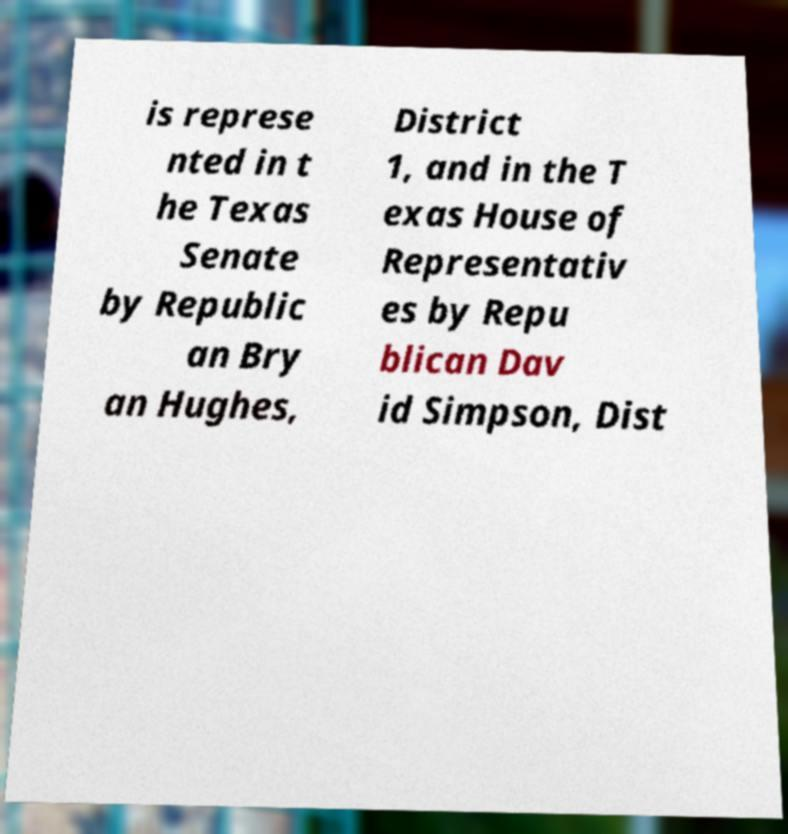Can you read and provide the text displayed in the image?This photo seems to have some interesting text. Can you extract and type it out for me? is represe nted in t he Texas Senate by Republic an Bry an Hughes, District 1, and in the T exas House of Representativ es by Repu blican Dav id Simpson, Dist 